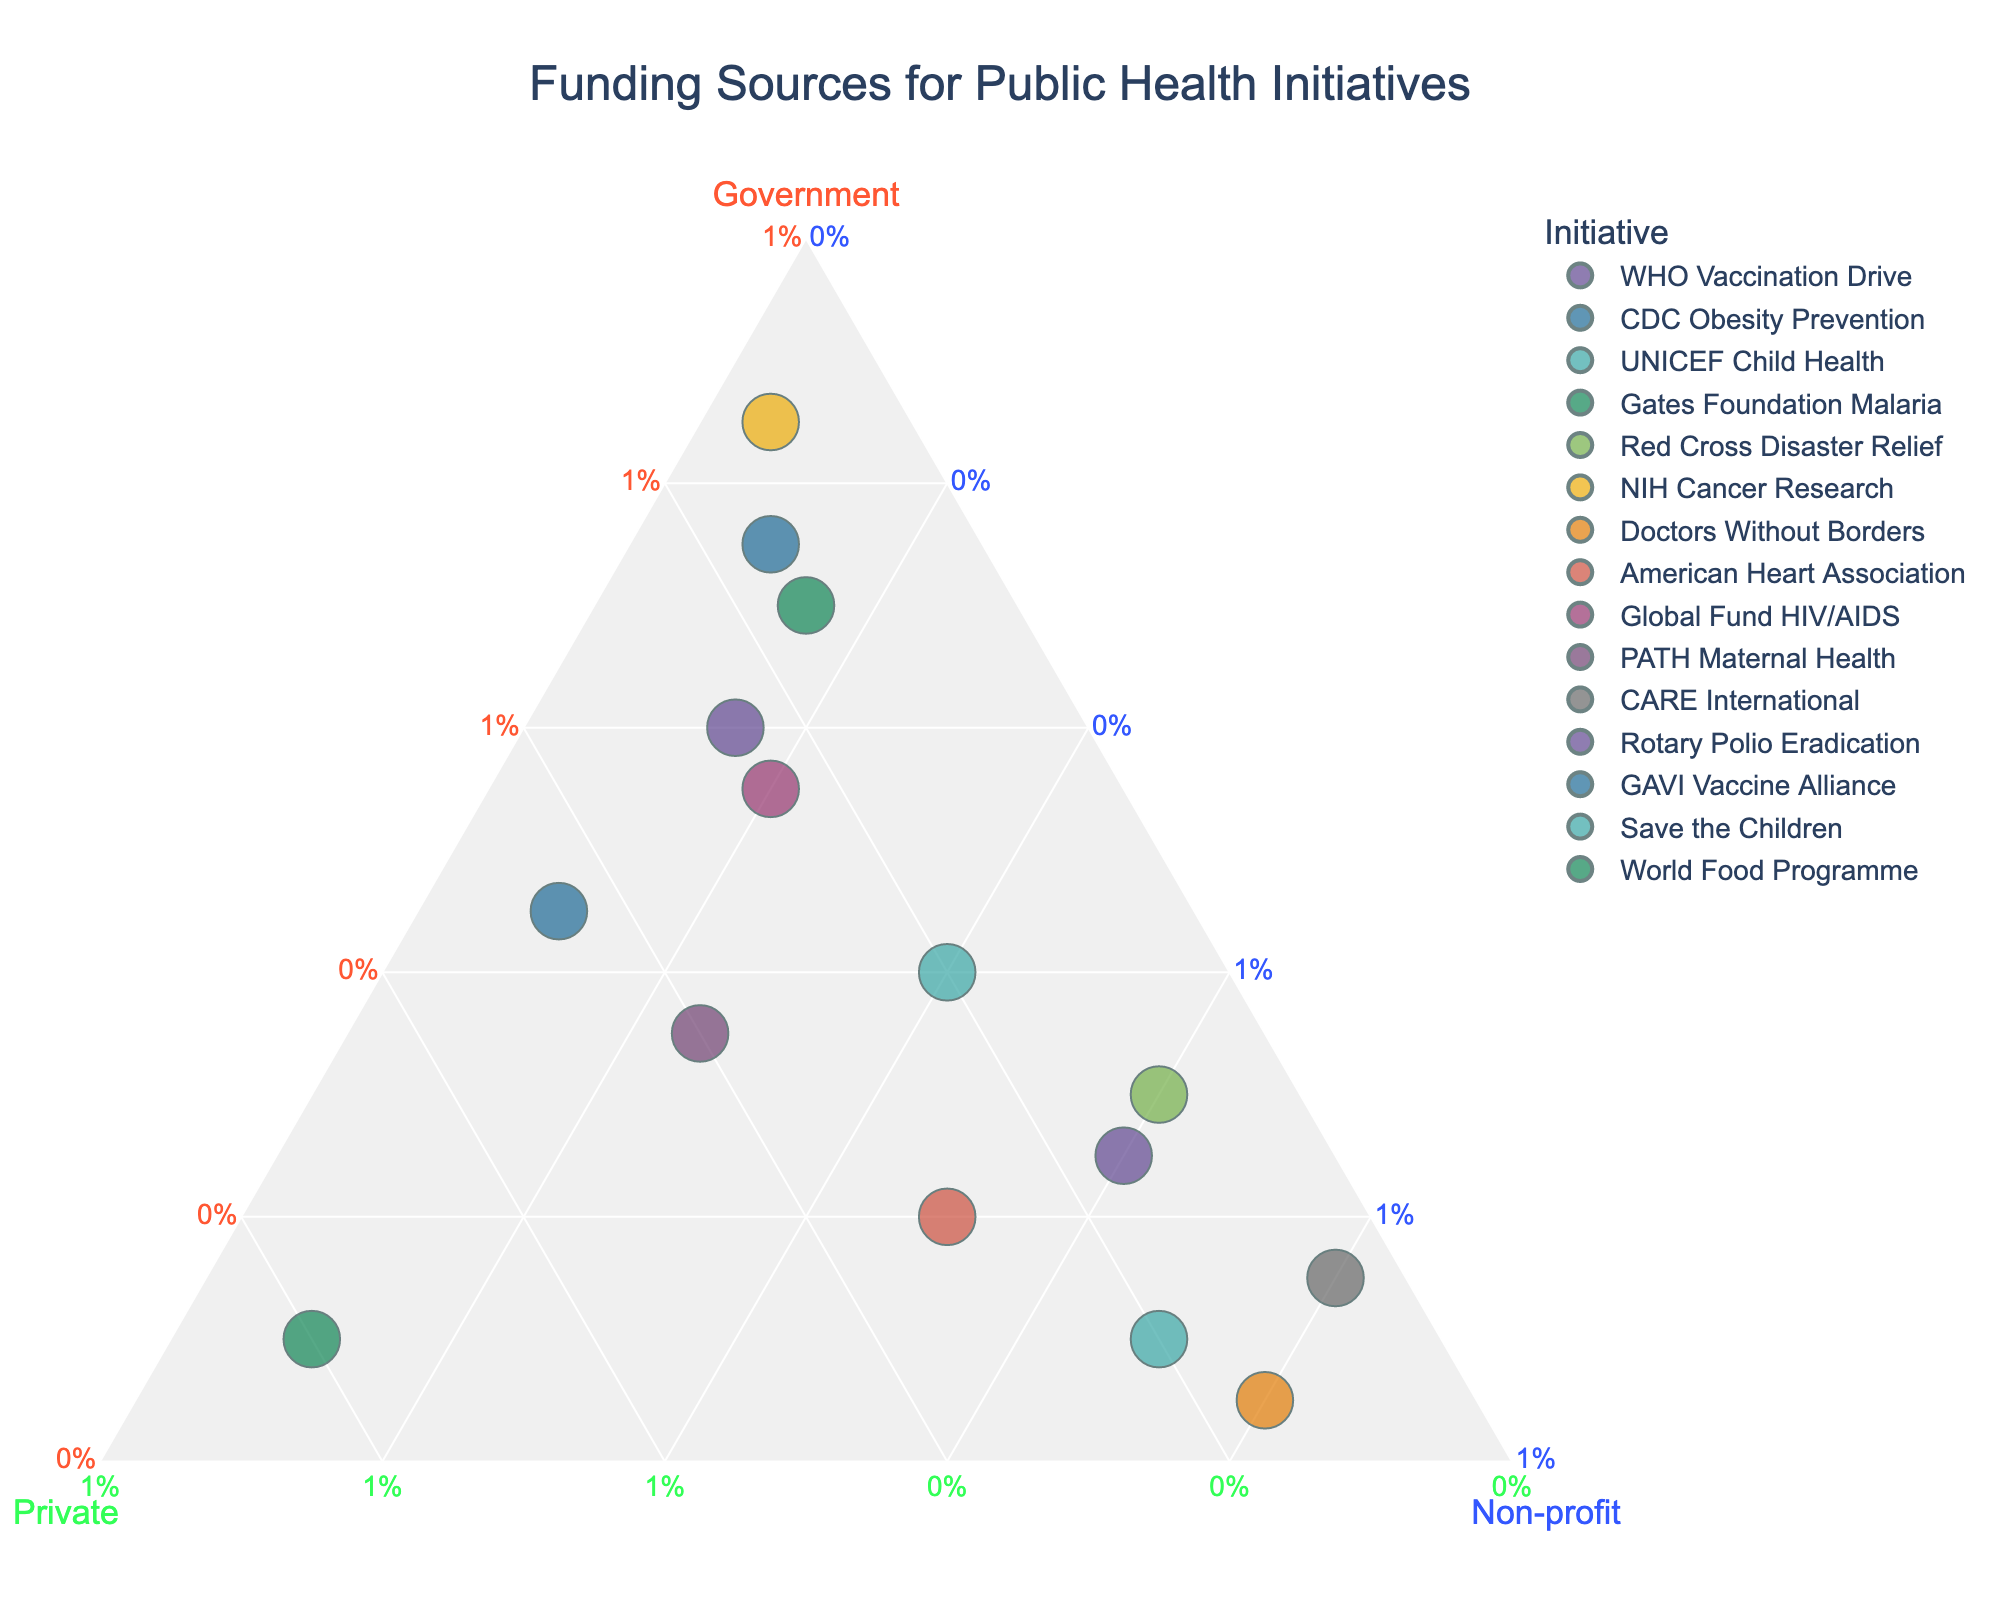In which initiative does the government provide the highest percentage of funding? Look at the ternary plot to identify the data point positioned closest to the apex labeled "Government". The "NIH Cancer Research" initiative is closest to this point with 85% funding from the government.
Answer: NIH Cancer Research What is the funding breakdown for the "Gates Foundation Malaria" initiative? Find the "Gates Foundation Malaria" data point on the plot and hover over it to see the detailed breakdown. The funding is 10% from the government, 80% from the private sector, and 10% from non-profit organizations.
Answer: 10% Government, 80% Private, 10% Non-profit Which initiative has the most balanced funding from all three sources? Look for the data point closest to the center of the ternary plot, where all three funding sources are relatively equal. "PATH Maternal Health" appears balanced compared to others with 35% Government, 40% Private, and 25% Non-profit.
Answer: PATH Maternal Health How many initiatives have over 50% government funding? Check the points located towards the "Government" apex and count those that surpass the 50% line. The initiatives are "WHO Vaccination Drive", "CDC Obesity Prevention", "NIH Cancer Research", "Global Fund HIV/AIDS", and "World Food Programme".
Answer: 5 initiatives Which sector provides the least funding for "Red Cross Disaster Relief"? Hover over the "Red Cross Disaster Relief" data point to see the funding details. The least funding comes from the private sector, which contributes 10%.
Answer: Private sector Compare the percentage of private sector funding between "American Heart Association" and "GAVI Vaccine Alliance". Which one receives more? Identify the points for "American Heart Association" and "GAVI Vaccine Alliance" and check their private sector funding. "GAVI Vaccine Alliance" receives 45% while "American Heart Association" receives 30%. Therefore, "GAVI Vaccine Alliance" receives more private sector funding.
Answer: GAVI Vaccine Alliance Which initiatives are predominantly funded by non-profit organizations? Look for points closer to the "Non-profit" apex and identify them. These include "Doctors Without Borders", "CARE International", and "Save the Children", each having 80% non-profit funding.
Answer: Doctors Without Borders, CARE International, Save the Children What percentage of funding does the government provide for "Rotary Polio Eradication"? Locate the "Rotary Polio Eradication" on the ternary plot and hover to reveal the breakdown. The government provides 25% of the funding.
Answer: 25% Which initiative receives the lowest percentage of government funding? Identify the point farthest from the "Government" apex. "Gates Foundation Malaria" and "Doctors Without Borders" are the farthest, each with only 5% from the government.
Answer: Gates Foundation Malaria, Doctors Without Borders What is the total percentage of private and non-profit sector funding for "UNICEF Child Health"? Locate "UNICEF Child Health" on the plot and sum up the percentages for private and non-profit sectors. Private sector contributes 20% and non-profit contributes 40%, totaling 60%.
Answer: 60% 